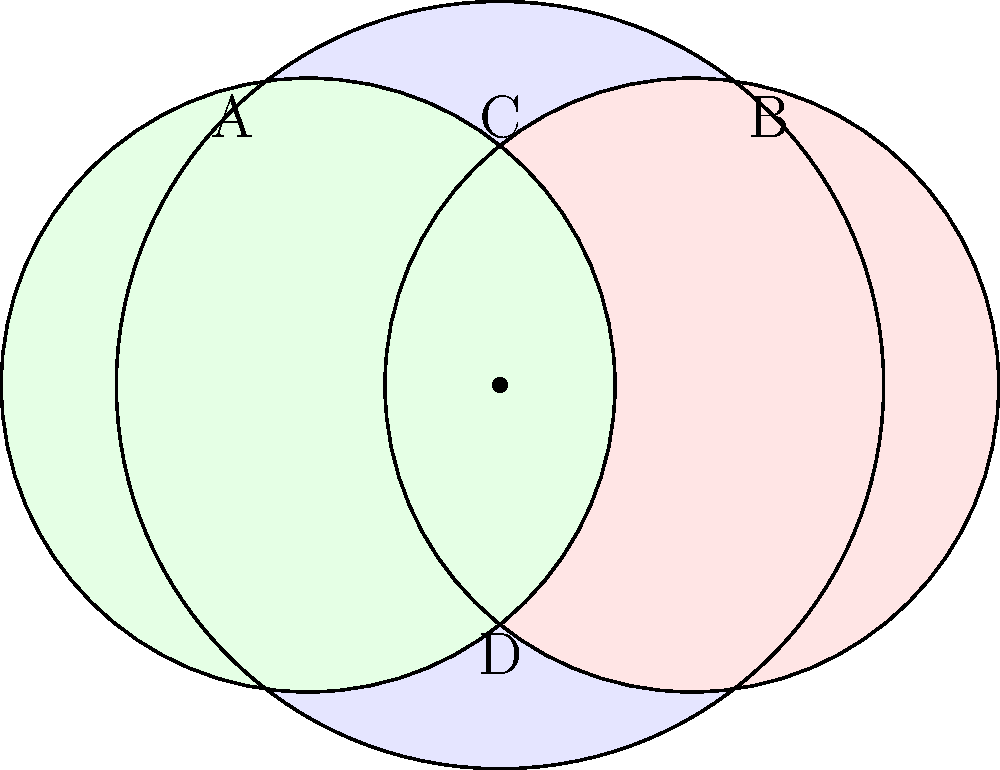In a local community organization focused on promoting family values and civic engagement, there are four subgroups: A (Youth Programs), B (Adult Education), C (Political Action), and D (Family Services). The Venn diagram above represents the overlapping memberships of these subgroups. If a member participates in all four subgroups, in which region of the diagram would they be represented? To answer this question, we need to analyze the Venn diagram and understand how it represents the relationships between the subgroups:

1. The diagram shows three overlapping circles, each representing a subgroup (A, B, and C).
2. The region D is represented by the area outside all three circles.
3. To be a member of all four subgroups (A, B, C, and D), an individual would need to be:
   a) Inside circle A
   b) Inside circle B
   c) Inside circle C
   d) Outside all circles (for D)

4. However, it's impossible to be simultaneously inside all three circles and outside all circles.
5. The only point that satisfies being inside all three circles (A, B, and C) is the center point where all three circles intersect.
6. This center point represents membership in A, B, and C, but not D.

Therefore, there is no region in the diagram that represents membership in all four subgroups simultaneously. The question, as posed with this Venn diagram, has no valid solution.
Answer: No such region exists in the given diagram. 